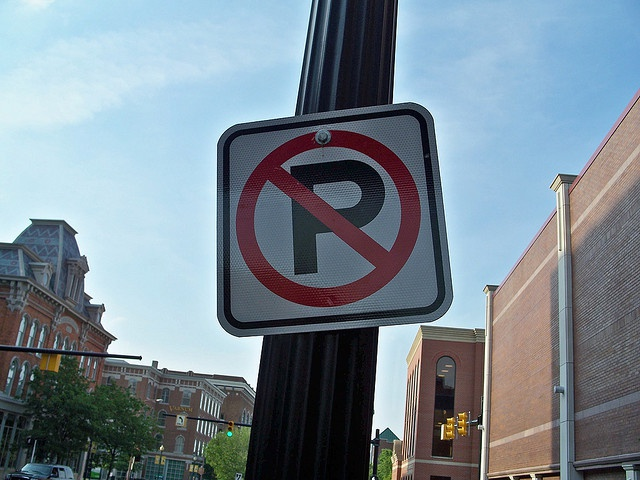Describe the objects in this image and their specific colors. I can see car in lightblue, black, blue, and gray tones, traffic light in lightblue, olive, and black tones, traffic light in lightblue, olive, black, and gray tones, traffic light in lightblue, olive, and maroon tones, and traffic light in lightblue, olive, black, gray, and cyan tones in this image. 